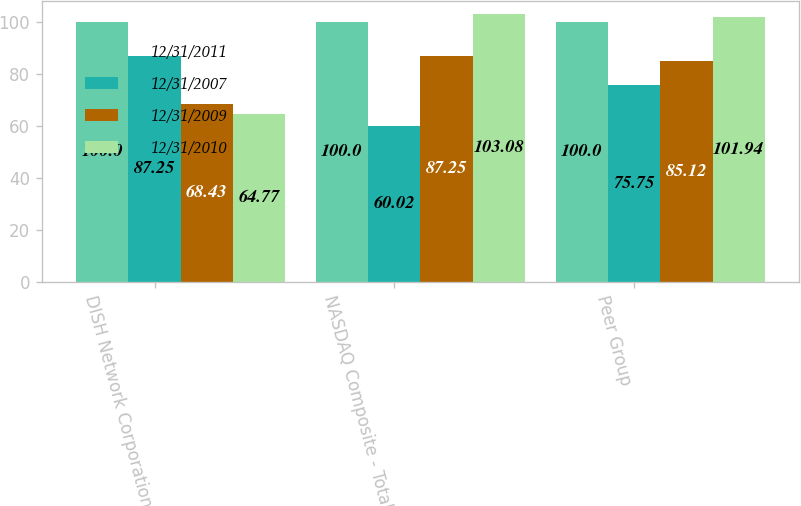Convert chart to OTSL. <chart><loc_0><loc_0><loc_500><loc_500><stacked_bar_chart><ecel><fcel>DISH Network Corporation<fcel>NASDAQ Composite - Total<fcel>Peer Group<nl><fcel>12/31/2011<fcel>100<fcel>100<fcel>100<nl><fcel>12/31/2007<fcel>87.25<fcel>60.02<fcel>75.75<nl><fcel>12/31/2009<fcel>68.43<fcel>87.25<fcel>85.12<nl><fcel>12/31/2010<fcel>64.77<fcel>103.08<fcel>101.94<nl></chart> 